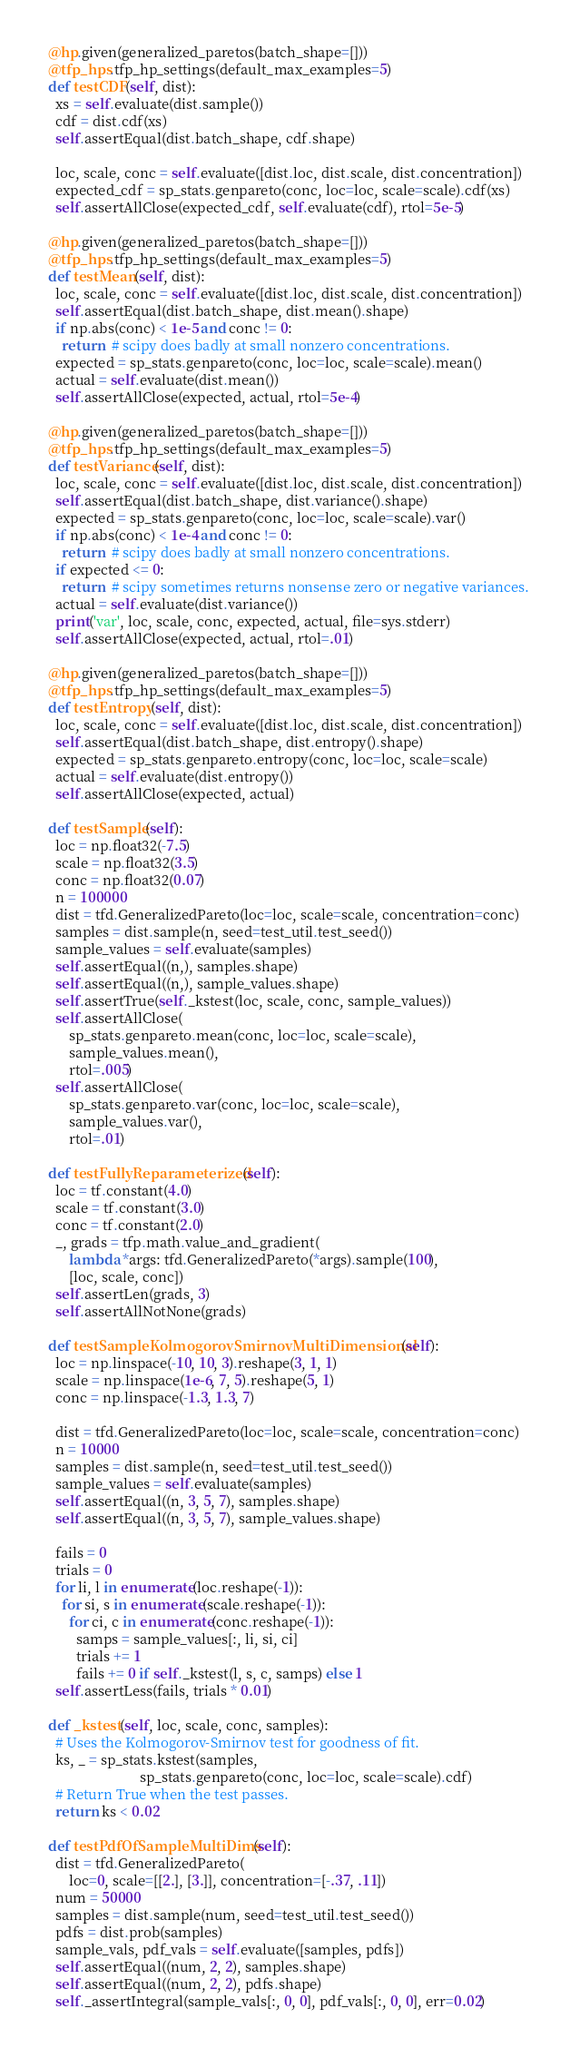Convert code to text. <code><loc_0><loc_0><loc_500><loc_500><_Python_>
  @hp.given(generalized_paretos(batch_shape=[]))
  @tfp_hps.tfp_hp_settings(default_max_examples=5)
  def testCDF(self, dist):
    xs = self.evaluate(dist.sample())
    cdf = dist.cdf(xs)
    self.assertEqual(dist.batch_shape, cdf.shape)

    loc, scale, conc = self.evaluate([dist.loc, dist.scale, dist.concentration])
    expected_cdf = sp_stats.genpareto(conc, loc=loc, scale=scale).cdf(xs)
    self.assertAllClose(expected_cdf, self.evaluate(cdf), rtol=5e-5)

  @hp.given(generalized_paretos(batch_shape=[]))
  @tfp_hps.tfp_hp_settings(default_max_examples=5)
  def testMean(self, dist):
    loc, scale, conc = self.evaluate([dist.loc, dist.scale, dist.concentration])
    self.assertEqual(dist.batch_shape, dist.mean().shape)
    if np.abs(conc) < 1e-5 and conc != 0:
      return  # scipy does badly at small nonzero concentrations.
    expected = sp_stats.genpareto(conc, loc=loc, scale=scale).mean()
    actual = self.evaluate(dist.mean())
    self.assertAllClose(expected, actual, rtol=5e-4)

  @hp.given(generalized_paretos(batch_shape=[]))
  @tfp_hps.tfp_hp_settings(default_max_examples=5)
  def testVariance(self, dist):
    loc, scale, conc = self.evaluate([dist.loc, dist.scale, dist.concentration])
    self.assertEqual(dist.batch_shape, dist.variance().shape)
    expected = sp_stats.genpareto(conc, loc=loc, scale=scale).var()
    if np.abs(conc) < 1e-4 and conc != 0:
      return  # scipy does badly at small nonzero concentrations.
    if expected <= 0:
      return  # scipy sometimes returns nonsense zero or negative variances.
    actual = self.evaluate(dist.variance())
    print('var', loc, scale, conc, expected, actual, file=sys.stderr)
    self.assertAllClose(expected, actual, rtol=.01)

  @hp.given(generalized_paretos(batch_shape=[]))
  @tfp_hps.tfp_hp_settings(default_max_examples=5)
  def testEntropy(self, dist):
    loc, scale, conc = self.evaluate([dist.loc, dist.scale, dist.concentration])
    self.assertEqual(dist.batch_shape, dist.entropy().shape)
    expected = sp_stats.genpareto.entropy(conc, loc=loc, scale=scale)
    actual = self.evaluate(dist.entropy())
    self.assertAllClose(expected, actual)

  def testSample(self):
    loc = np.float32(-7.5)
    scale = np.float32(3.5)
    conc = np.float32(0.07)
    n = 100000
    dist = tfd.GeneralizedPareto(loc=loc, scale=scale, concentration=conc)
    samples = dist.sample(n, seed=test_util.test_seed())
    sample_values = self.evaluate(samples)
    self.assertEqual((n,), samples.shape)
    self.assertEqual((n,), sample_values.shape)
    self.assertTrue(self._kstest(loc, scale, conc, sample_values))
    self.assertAllClose(
        sp_stats.genpareto.mean(conc, loc=loc, scale=scale),
        sample_values.mean(),
        rtol=.005)
    self.assertAllClose(
        sp_stats.genpareto.var(conc, loc=loc, scale=scale),
        sample_values.var(),
        rtol=.01)

  def testFullyReparameterized(self):
    loc = tf.constant(4.0)
    scale = tf.constant(3.0)
    conc = tf.constant(2.0)
    _, grads = tfp.math.value_and_gradient(
        lambda *args: tfd.GeneralizedPareto(*args).sample(100),
        [loc, scale, conc])
    self.assertLen(grads, 3)
    self.assertAllNotNone(grads)

  def testSampleKolmogorovSmirnovMultiDimensional(self):
    loc = np.linspace(-10, 10, 3).reshape(3, 1, 1)
    scale = np.linspace(1e-6, 7, 5).reshape(5, 1)
    conc = np.linspace(-1.3, 1.3, 7)

    dist = tfd.GeneralizedPareto(loc=loc, scale=scale, concentration=conc)
    n = 10000
    samples = dist.sample(n, seed=test_util.test_seed())
    sample_values = self.evaluate(samples)
    self.assertEqual((n, 3, 5, 7), samples.shape)
    self.assertEqual((n, 3, 5, 7), sample_values.shape)

    fails = 0
    trials = 0
    for li, l in enumerate(loc.reshape(-1)):
      for si, s in enumerate(scale.reshape(-1)):
        for ci, c in enumerate(conc.reshape(-1)):
          samps = sample_values[:, li, si, ci]
          trials += 1
          fails += 0 if self._kstest(l, s, c, samps) else 1
    self.assertLess(fails, trials * 0.01)

  def _kstest(self, loc, scale, conc, samples):
    # Uses the Kolmogorov-Smirnov test for goodness of fit.
    ks, _ = sp_stats.kstest(samples,
                            sp_stats.genpareto(conc, loc=loc, scale=scale).cdf)
    # Return True when the test passes.
    return ks < 0.02

  def testPdfOfSampleMultiDims(self):
    dist = tfd.GeneralizedPareto(
        loc=0, scale=[[2.], [3.]], concentration=[-.37, .11])
    num = 50000
    samples = dist.sample(num, seed=test_util.test_seed())
    pdfs = dist.prob(samples)
    sample_vals, pdf_vals = self.evaluate([samples, pdfs])
    self.assertEqual((num, 2, 2), samples.shape)
    self.assertEqual((num, 2, 2), pdfs.shape)
    self._assertIntegral(sample_vals[:, 0, 0], pdf_vals[:, 0, 0], err=0.02)</code> 